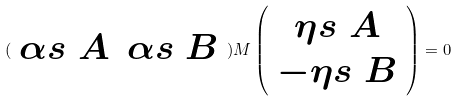Convert formula to latex. <formula><loc_0><loc_0><loc_500><loc_500>( \begin{array} { c c } \alpha s { \ A } & \alpha s { \ B } \end{array} ) M \left ( \begin{array} { c } \eta s { \ A } \\ - \eta s { \ B } \end{array} \right ) = 0</formula> 